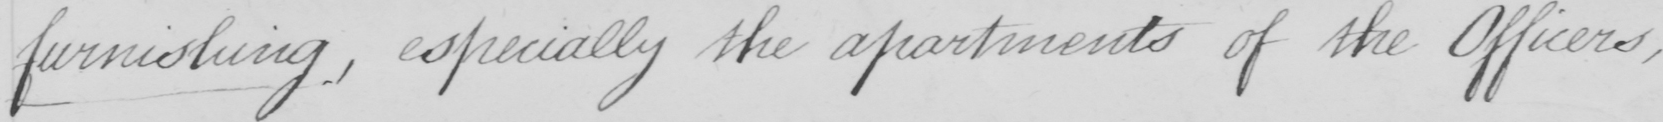Please provide the text content of this handwritten line. furnishing , especially the apartments of the Officers , 